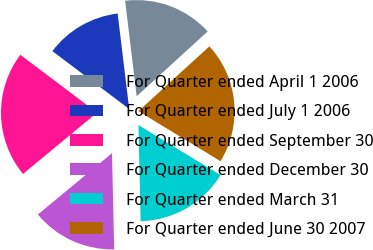Convert chart. <chart><loc_0><loc_0><loc_500><loc_500><pie_chart><fcel>For Quarter ended April 1 2006<fcel>For Quarter ended July 1 2006<fcel>For Quarter ended September 30<fcel>For Quarter ended December 30<fcel>For Quarter ended March 31<fcel>For Quarter ended June 30 2007<nl><fcel>15.14%<fcel>12.81%<fcel>21.27%<fcel>14.37%<fcel>15.92%<fcel>20.49%<nl></chart> 